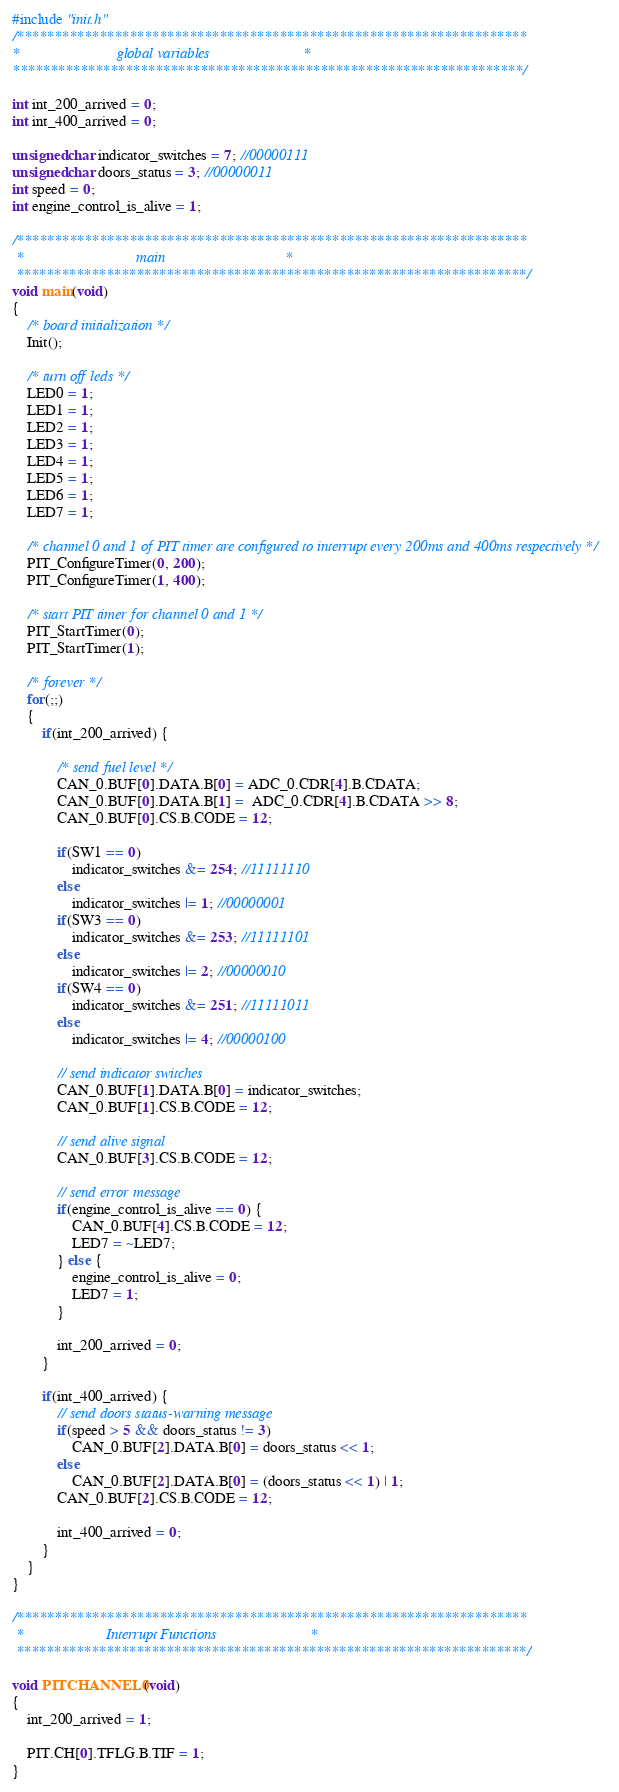Convert code to text. <code><loc_0><loc_0><loc_500><loc_500><_C_>#include "init.h"
/********************************************************************
*                          global variables                         *
********************************************************************/

int int_200_arrived = 0;
int int_400_arrived = 0; 

unsigned char indicator_switches = 7; //00000111
unsigned char doors_status = 3; //00000011
int speed = 0;
int engine_control_is_alive = 1;

/********************************************************************
 *                              main                                *
 ********************************************************************/
void main(void)
{
    /* board initialization */
    Init();

    /* turn off leds */
    LED0 = 1;
    LED1 = 1;
    LED2 = 1;
    LED3 = 1;
    LED4 = 1;
    LED5 = 1;
    LED6 = 1;
    LED7 = 1; 

	/* channel 0 and 1 of PIT timer are configured to interrupt every 200ms and 400ms respectively */
	PIT_ConfigureTimer(0, 200);
	PIT_ConfigureTimer(1, 400);
	
	/* start PIT timer for channel 0 and 1 */
	PIT_StartTimer(0);
	PIT_StartTimer(1);  

    /* forever */
    for(;;)
    {
        if(int_200_arrived) {

			/* send fuel level */
			CAN_0.BUF[0].DATA.B[0] = ADC_0.CDR[4].B.CDATA;
			CAN_0.BUF[0].DATA.B[1] =  ADC_0.CDR[4].B.CDATA >> 8;		
			CAN_0.BUF[0].CS.B.CODE = 12;
			
			if(SW1 == 0)
				indicator_switches &= 254; //11111110
			else 
				indicator_switches |= 1; //00000001
			if(SW3 == 0)
				indicator_switches &= 253; //11111101
			else 
				indicator_switches |= 2; //00000010
			if(SW4 == 0)
				indicator_switches &= 251; //11111011
			else 
				indicator_switches |= 4; //00000100
			
			// send indicator switches
			CAN_0.BUF[1].DATA.B[0] = indicator_switches;
			CAN_0.BUF[1].CS.B.CODE = 12;
			
			// send alive signal
			CAN_0.BUF[3].CS.B.CODE = 12;
			
			// send error message
			if(engine_control_is_alive == 0) {
				CAN_0.BUF[4].CS.B.CODE = 12;
				LED7 = ~LED7;
			} else {
				engine_control_is_alive = 0;
				LED7 = 1;
			}
			
			int_200_arrived = 0;
		} 
		
		if(int_400_arrived) {
			// send doors status-warning message
			if(speed > 5 && doors_status != 3)
				CAN_0.BUF[2].DATA.B[0] = doors_status << 1;
			else
				CAN_0.BUF[2].DATA.B[0] = (doors_status << 1) | 1;
			CAN_0.BUF[2].CS.B.CODE = 12;
			
			int_400_arrived = 0;
		}
    }
}

/********************************************************************
 *                      Interrupt Functions                         *
 ********************************************************************/  

void PITCHANNEL0(void)
{
    int_200_arrived = 1;
	
    PIT.CH[0].TFLG.B.TIF = 1;
}
</code> 